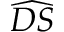<formula> <loc_0><loc_0><loc_500><loc_500>\widehat { D S }</formula> 